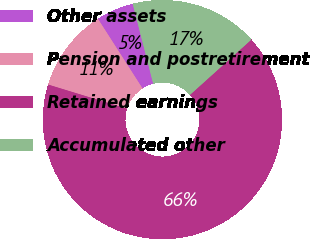Convert chart to OTSL. <chart><loc_0><loc_0><loc_500><loc_500><pie_chart><fcel>Other assets<fcel>Pension and postretirement<fcel>Retained earnings<fcel>Accumulated other<nl><fcel>5.07%<fcel>11.2%<fcel>66.39%<fcel>17.33%<nl></chart> 